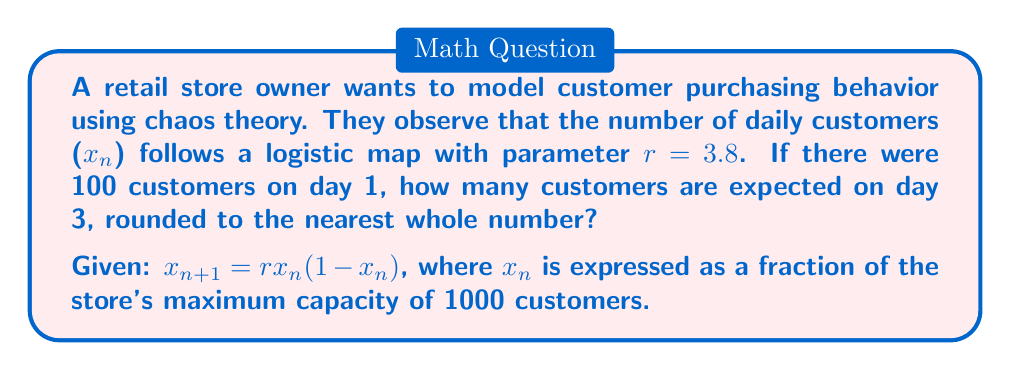Could you help me with this problem? Let's approach this step-by-step:

1) We're given that $r = 3.8$ and the initial number of customers $x_0 = 100$.

2) First, we need to express $x_0$ as a fraction of the maximum capacity:
   $x_0 = 100/1000 = 0.1$

3) Now we can use the logistic map equation to find $x_1$:
   $x_1 = rx_0(1-x_0)$
   $x_1 = 3.8 * 0.1 * (1-0.1)$
   $x_1 = 3.8 * 0.1 * 0.9 = 0.342$

4) We can repeat this process to find $x_2$:
   $x_2 = rx_1(1-x_1)$
   $x_2 = 3.8 * 0.342 * (1-0.342)$
   $x_2 = 3.8 * 0.342 * 0.658 = 0.8544876$

5) To get the actual number of customers, we multiply by 1000:
   $0.8544876 * 1000 = 854.4876$

6) Rounding to the nearest whole number:
   854 customers are expected on day 3.

This demonstrates how chaos theory can model seemingly unpredictable customer behavior, showing significant fluctuations even over a short period.
Answer: 854 